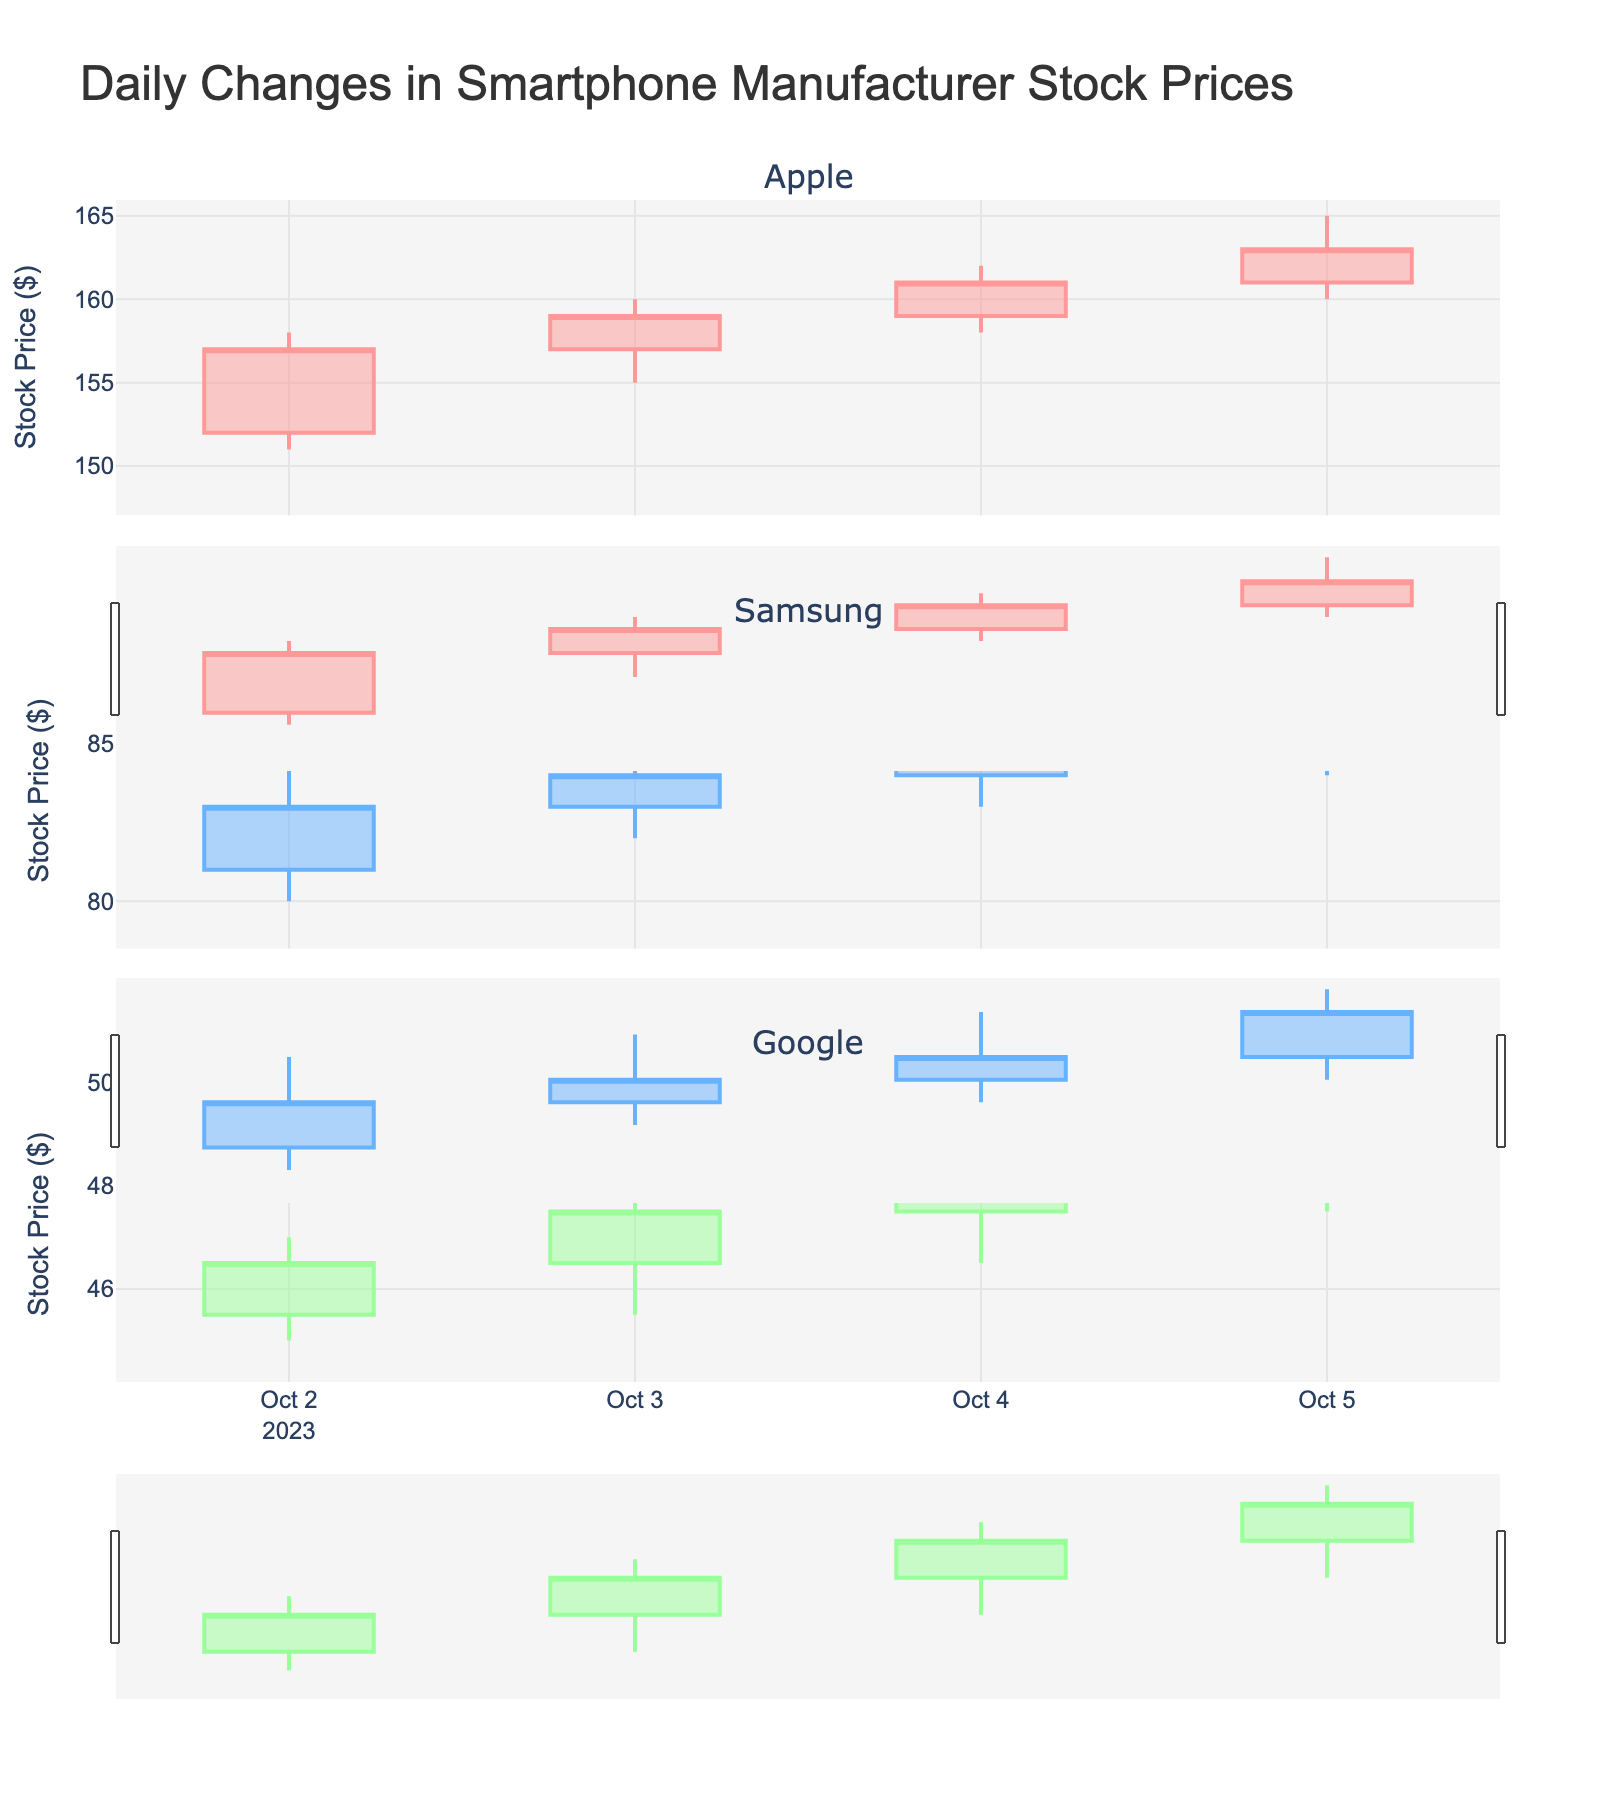What's the title of the figure? The title is located at the top of the figure and is clearly visible. It states the main focus of the visualized data.
Answer: Daily Changes in Smartphone Manufacturer Stock Prices How many manufacturers' stock prices are shown in the figure? The figure has 3 separate subplots, each titled with the name of a manufacturer. This indicates 3 manufacturers are included.
Answer: 3 What is the stock price range for Apple on October 2? Refer to the candlestick for Apple on October 2. The top and bottom of the candlestick represent the High (158.00) and Low (151.00) prices respectively.
Answer: 151.00 to 158.00 Between Apple, Samsung, and Google, which manufacturer had the highest closing price on October 1? Look at the closing prices for all three manufacturers on October 1. Compare 152.00 (Apple), 81.00 (Samsung), and 45.50 (Google). The highest is 152.00.
Answer: Apple On which date did Samsung have the highest stock price during the week? Identify the highest point in the candlestick plot for Samsung. The highest point (88.00) appears on October 5.
Answer: October 5 What is the average closing price for Google from October 1 to October 5? Add up the closing prices for Google (45.50, 46.50, 47.50, 48.50, 49.50) and divide by the number of observations (5). The sum is 237.5, and the average is 237.5/5.
Answer: 47.50 Which manufacturer shows the most significant increase in stock price from October 1 to October 2? Calculate the difference in closing prices for each manufacturer: Apple (157 - 152 = 5), Samsung (83 - 81 = 2), Google (46.50 - 45.50 = 1). The most significant increase is for Apple.
Answer: Apple Did any manufacturer experience a drop in stock price on any given day? Check each candlestick, specifically comparing the closing price of one day with the previous day's closing price. None of the manufacturers experienced a drop; all closing prices are higher each day.
Answer: No What was the volume for Samsung on October 3? Refer to the volume information located in the dataset for Samsung on October 3, which shows the number of shares traded.
Answer: 1600000 